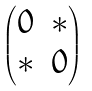<formula> <loc_0><loc_0><loc_500><loc_500>\begin{pmatrix} 0 & \ast \\ \ast & 0 \end{pmatrix}</formula> 